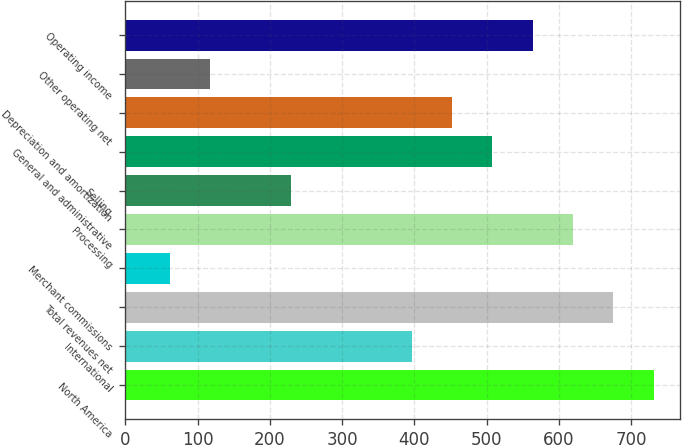<chart> <loc_0><loc_0><loc_500><loc_500><bar_chart><fcel>North America<fcel>International<fcel>Total revenues net<fcel>Merchant commissions<fcel>Processing<fcel>Selling<fcel>General and administrative<fcel>Depreciation and amortization<fcel>Other operating net<fcel>Operating income<nl><fcel>730.79<fcel>396.41<fcel>675.06<fcel>62.03<fcel>619.33<fcel>229.22<fcel>507.87<fcel>452.14<fcel>117.76<fcel>563.6<nl></chart> 